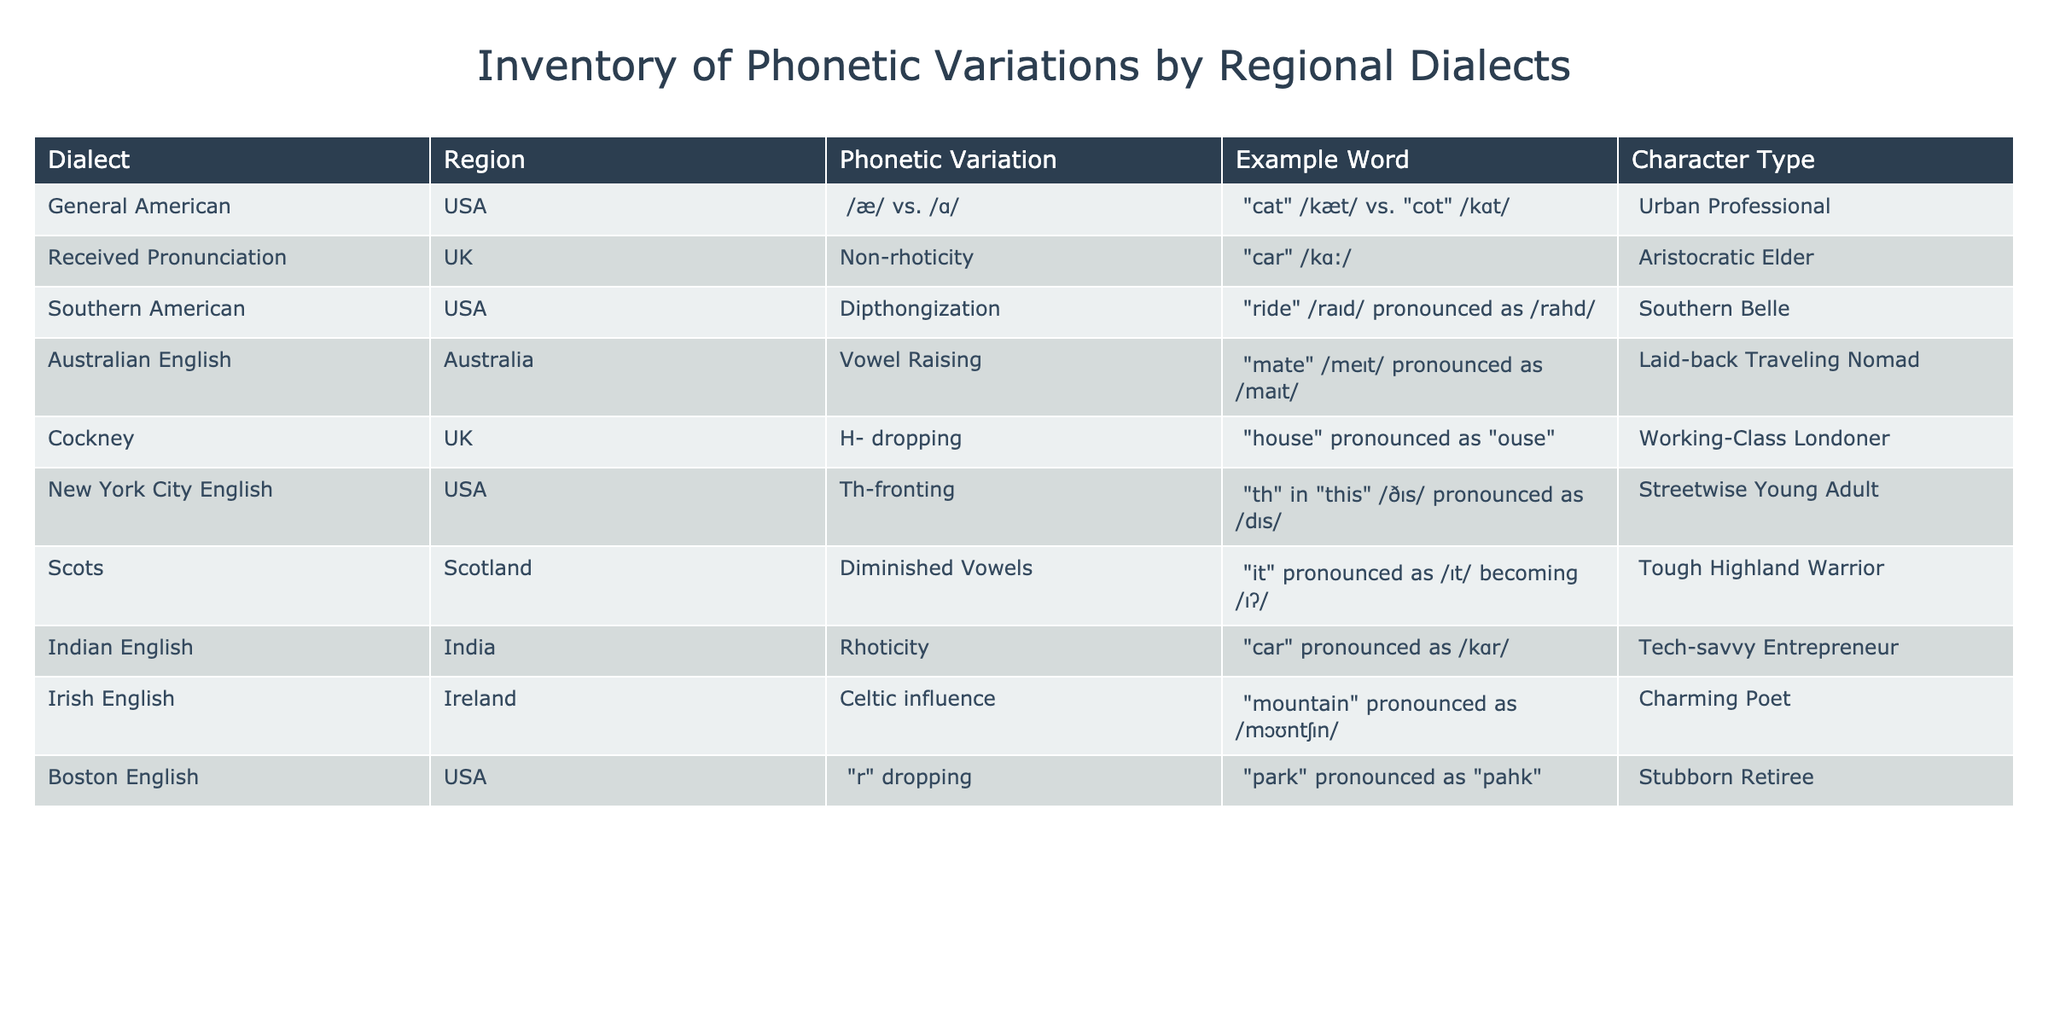What is the phonetic variation associated with the Southern American dialect? The table shows that the Southern American dialect has a phonetic variation of diphthongization. This is evident in the example provided for this dialect, which indicates how a word is pronounced differently.
Answer: Diphthongization Which character type is represented by Received Pronunciation? By examining the table, we can see that Received Pronunciation is associated with the character type "Aristocratic Elder." This information is directly taken from the relevant row of the table.
Answer: Aristocratic Elder How many dialects in the table have a non-rhoticity feature? The Non-rhoticity feature appears in the Received Pronunciation dialect only. Therefore, we can conclude that there is one dialect with this phonetic variation.
Answer: 1 Is the "r" dropping feature found in both Boston English and Received Pronunciation? The table indicates that "r" dropping is present in Boston English but not in Received Pronunciation, which has a different phonetic variation of non-rhoticity. This confirms that the statement is false.
Answer: No Which character types do the Urban Professional and the Streetwise Young Adult share in terms of their dialects? The Urban Professional speaks General American, while the Streetwise Young Adult speaks New York City English. Both dialects belong to the USA, but they represent different character types. Thus, they do not share a character type but share their regional origin.
Answer: Different character types Find the example word for the Cockney dialect and explain its phonetic variation. The example word for Cockney is "house," which is pronounced as "ouse." The phonetic variation here is the dropping of the "h" sound at the beginning of the word, a significant characteristic of Cockney speech.
Answer: "ouse" What distinct phonetic feature does Irish English exhibit in the word "mountain"? The table indicates that Irish English exhibits a Celtic influence when pronouncing the word "mountain," resulting in a pronunciation of /mɔʊntʃɪn/. This showcases how dialects can impact word pronunciation significantly.
Answer: Celtic influence How many dialects from the USA exhibit rhoticity, and which are they? The table indicates two dialects from the USA: General American and Southern American. Rhoticity is evident in the general pronunciation style across both dialects, making a total of two dialects exhibiting this feature.
Answer: 2 dialects: General American, Southern American 